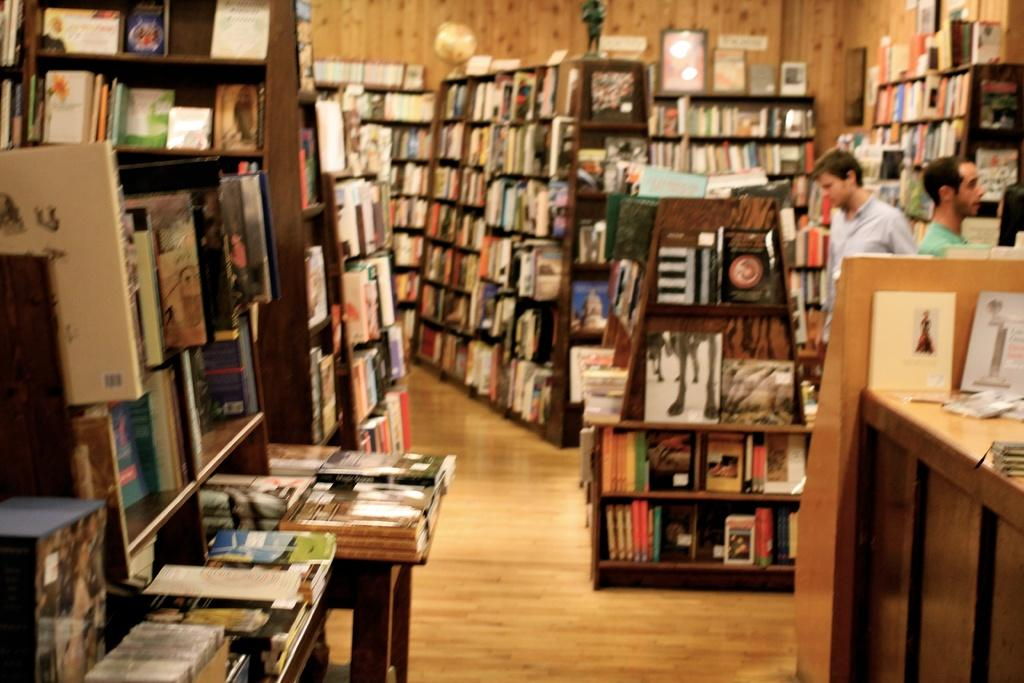What type of furniture is present in the room? There are bookshelves in the room. What are the bookshelves filled with? The bookshelves are filled with books. Can you describe the man's position in the room? There is a man standing in one corner of the room. What is the man doing in the room? The man is staring at the bookshelves. What type of beef is being served in the room? There is no mention of beef or any food in the image, so it cannot be determined if any type of beef is being served. Does the man feel any shame while staring at the bookshelves? The image does not provide any information about the man's emotions, so it cannot be determined if he feels any shame. 